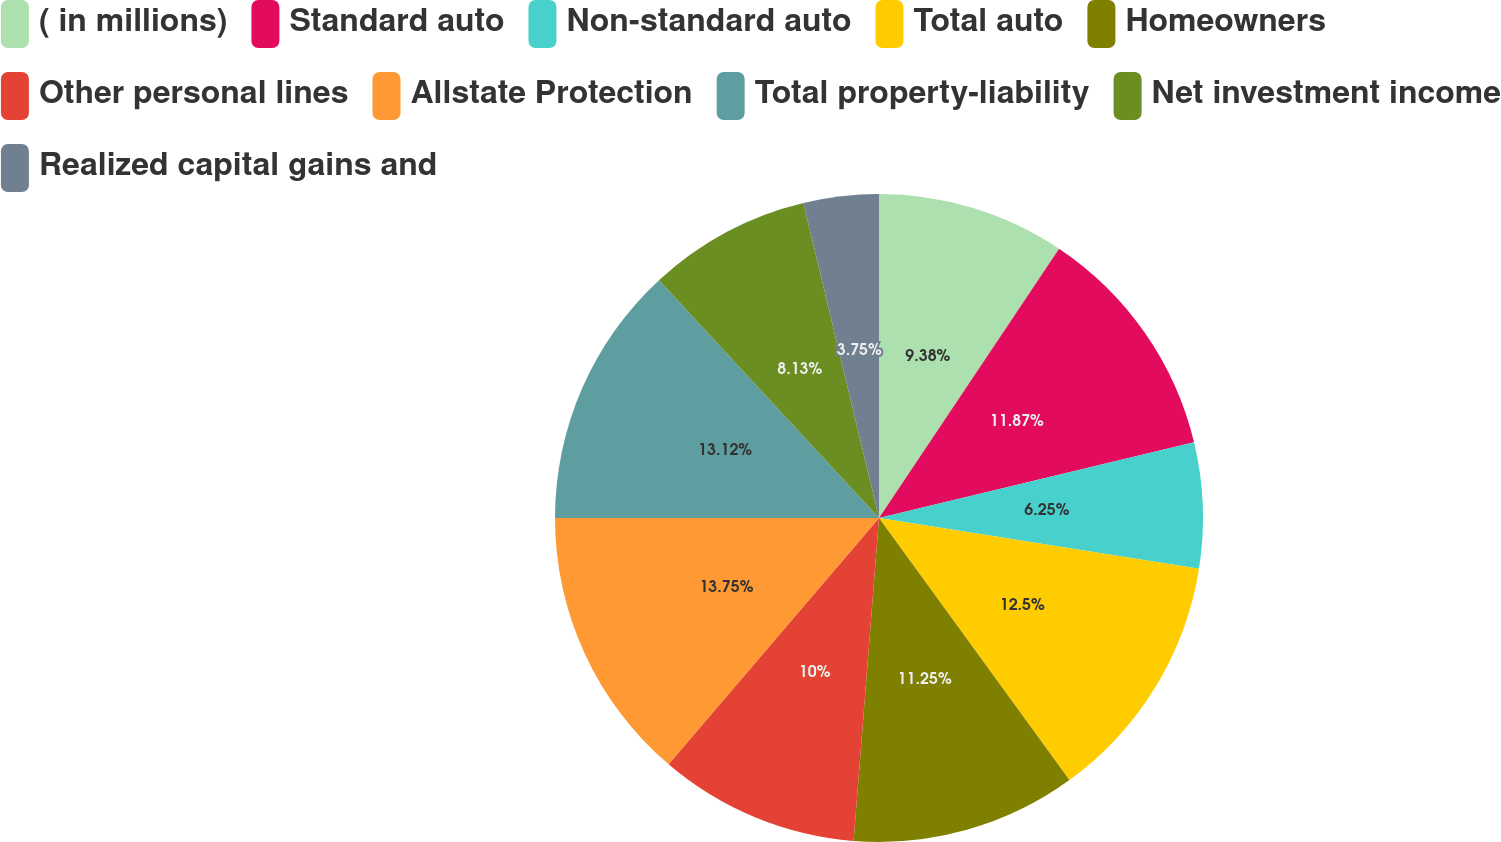<chart> <loc_0><loc_0><loc_500><loc_500><pie_chart><fcel>( in millions)<fcel>Standard auto<fcel>Non-standard auto<fcel>Total auto<fcel>Homeowners<fcel>Other personal lines<fcel>Allstate Protection<fcel>Total property-liability<fcel>Net investment income<fcel>Realized capital gains and<nl><fcel>9.38%<fcel>11.87%<fcel>6.25%<fcel>12.5%<fcel>11.25%<fcel>10.0%<fcel>13.75%<fcel>13.12%<fcel>8.13%<fcel>3.75%<nl></chart> 